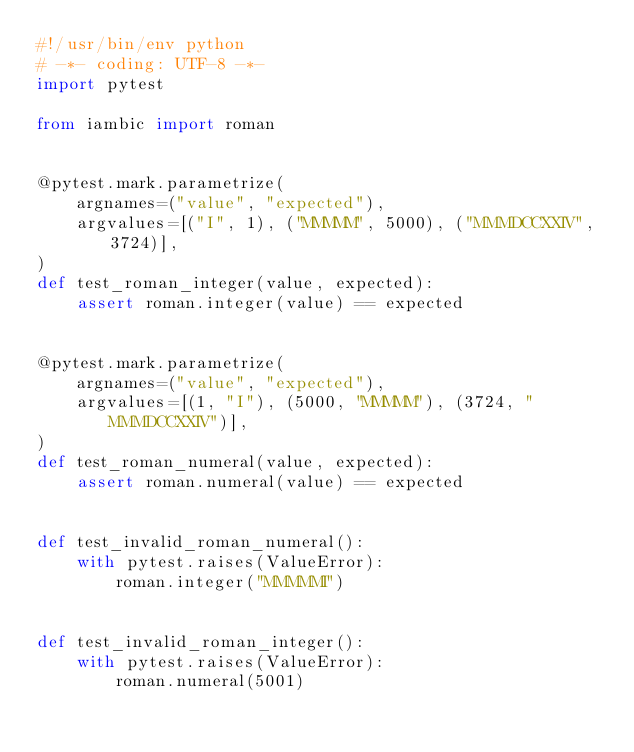Convert code to text. <code><loc_0><loc_0><loc_500><loc_500><_Python_>#!/usr/bin/env python
# -*- coding: UTF-8 -*-
import pytest

from iambic import roman


@pytest.mark.parametrize(
    argnames=("value", "expected"),
    argvalues=[("I", 1), ("MMMMM", 5000), ("MMMDCCXXIV", 3724)],
)
def test_roman_integer(value, expected):
    assert roman.integer(value) == expected


@pytest.mark.parametrize(
    argnames=("value", "expected"),
    argvalues=[(1, "I"), (5000, "MMMMM"), (3724, "MMMDCCXXIV")],
)
def test_roman_numeral(value, expected):
    assert roman.numeral(value) == expected


def test_invalid_roman_numeral():
    with pytest.raises(ValueError):
        roman.integer("MMMMMI")


def test_invalid_roman_integer():
    with pytest.raises(ValueError):
        roman.numeral(5001)
</code> 